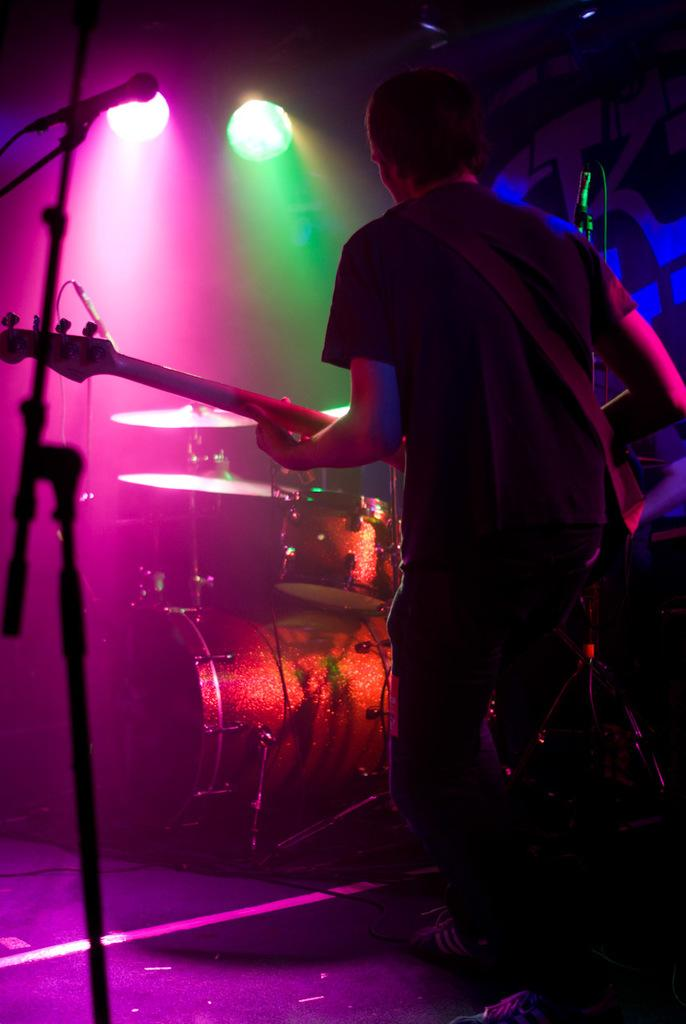What is the man in the image doing? The man is standing in the image and holding a guitar. What object is present in the image that is commonly used for amplifying sound? There is a microphone with a stand in the image. What other musical instrument can be seen in the image? There is a musical instrument in the image, but it is not specified which one. What can be seen in the background of the image that might be used for stage lighting? There are focusing lights in the background of the image. What direction is the man facing in the image? The provided facts do not specify the direction the man is facing in the image. What type of shovel is being used by the man in the image? There is no shovel or spade present in the image. 